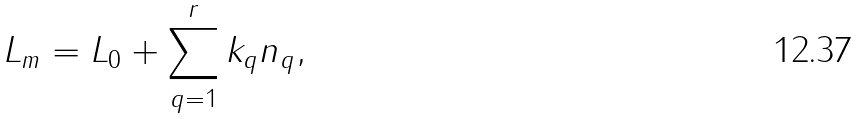Convert formula to latex. <formula><loc_0><loc_0><loc_500><loc_500>L _ { m } = L _ { 0 } + \sum _ { q = 1 } ^ { r } k _ { q } n _ { q } ,</formula> 